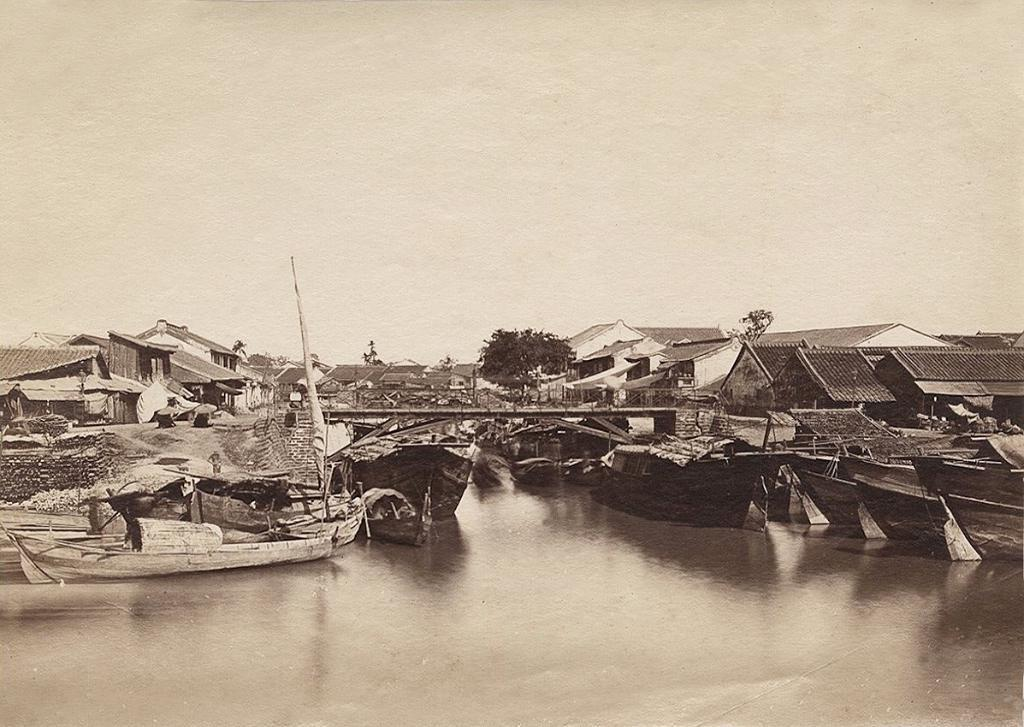What type of structures can be seen in the image? There are houses in the image. What other objects are visible in the image? There are boats and trees visible in the image. What is the primary natural element in the image? There is water visible in the image. What can be seen in the background of the image? The sky is visible in the background of the image. How many girls are holding thread in the image? There are no girls or thread present in the image. What type of mist can be seen in the image? There is no mist visible in the image. 